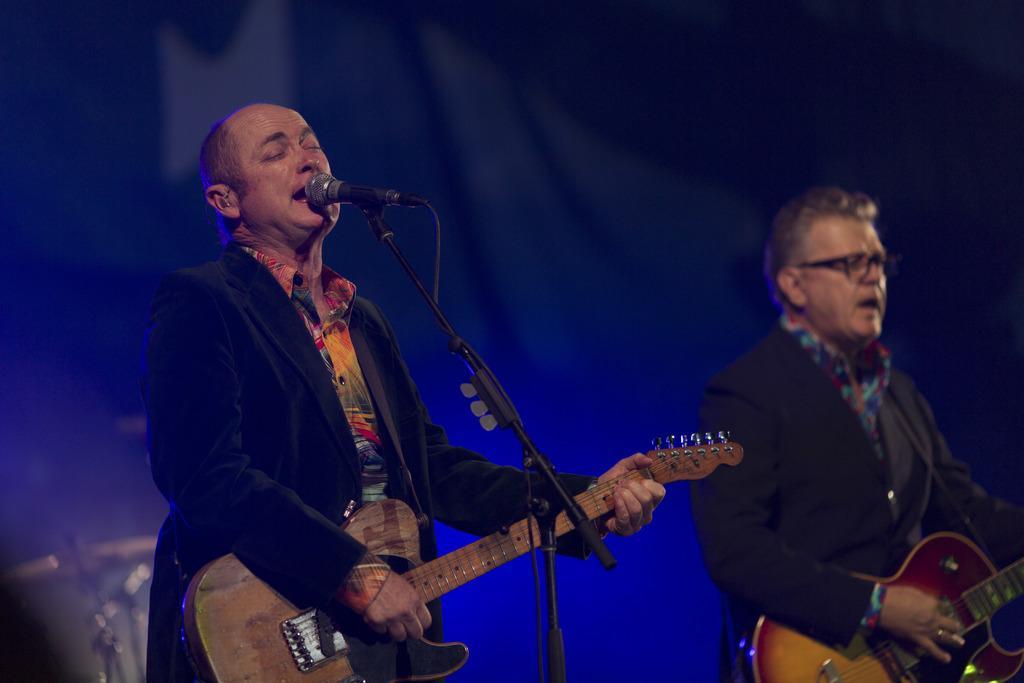Could you give a brief overview of what you see in this image? As we can see in the image there are two people holding guitars and there is a mic. 